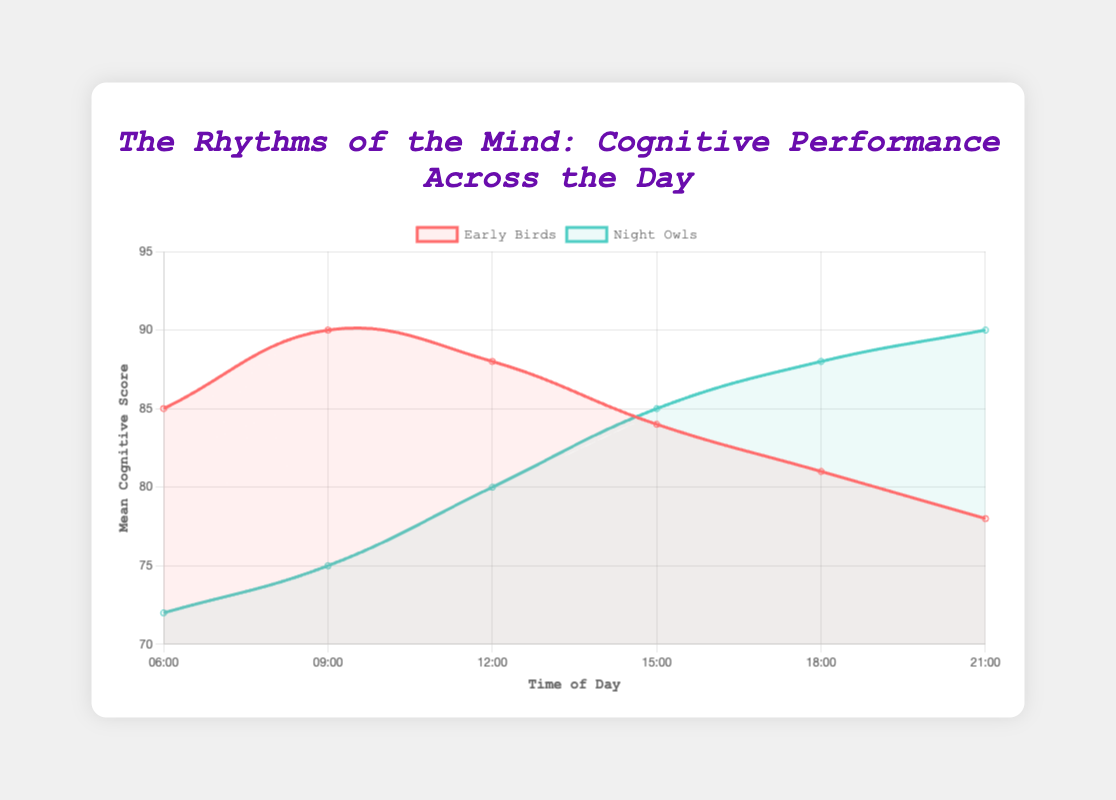What's the peak cognitive score for Early Birds, and at what time does it occur? Check the Early Birds line in the plot and identify the highest point. The highest score is 90 at 9:00.
Answer: 90 at 09:00 Compare the cognitive scores of Early Birds and Night Owls at 06:00. Which group performs better? Look at the scores at 06:00 for both groups. Early Birds have a score of 85, while Night Owls have a score of 72.
Answer: Early Birds Which time of the day shows the biggest difference in cognitive scores between Early Birds and Night Owls? Subtract the Night Owls' scores from Early Birds' scores for each time slot and find the maximum difference. At 06:00, the difference is 85 - 72 = 13, which is the largest gap.
Answer: 06:00 At what time do Night Owls surpass Early Birds in cognitive performance? Find the time where the Night Owls' line exceeds the Early Birds' line. This occurs starting at 15:00 and continues through 18:00 and 21:00.
Answer: 15:00 Calculate the mean cognitive score of Early Birds across the day. Sum the Early Birds' scores and divide by the number of time points: (85 + 90 + 88 + 84 + 81 + 78) / 6 = 84.33.
Answer: 84.33 How does the cognitive score of Night Owls at 18:00 compare to that of Early Birds at 18:00? Check the scores at 18:00 for both groups. Night Owls have a score of 88, and Early Birds have a score of 81.
Answer: Higher by 7 points Identify the time period where the cognitive scores of both groups are closest. Compare the differences in scores at each time point: 06:00 (13), 09:00 (15), 12:00 (8), 15:00 (1), 18:00 (7), 21:00 (12). The closest scores are at 15:00 with a difference of 1.
Answer: 15:00 What's the average cognitive score for Night Owls during the evening (18:00 and 21:00)? Sum the Night Owls' scores at 18:00 and 21:00 and divide by 2: (88 + 90) / 2 = 89.
Answer: 89 Which group shows more variance in cognitive performance throughout the day? Compare the standard deviations for each group. Early Birds' standard deviations: [5, 6, 7, 5, 8, 6], Night Owls': [10, 9, 8, 7, 6, 5]. Night Owls have higher deviations.
Answer: Night Owls 